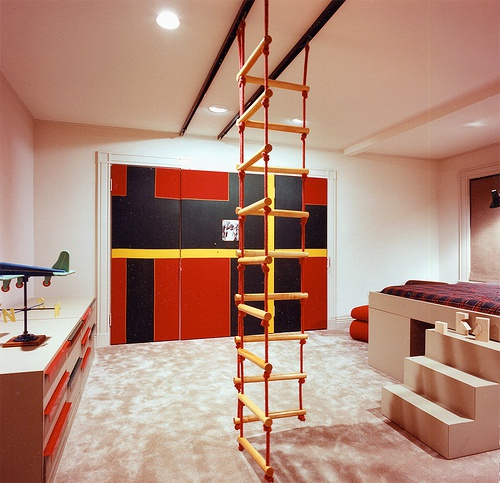Describe the objects in this image and their specific colors. I can see bed in salmon, tan, brown, and maroon tones and airplane in salmon, black, darkgreen, gray, and maroon tones in this image. 